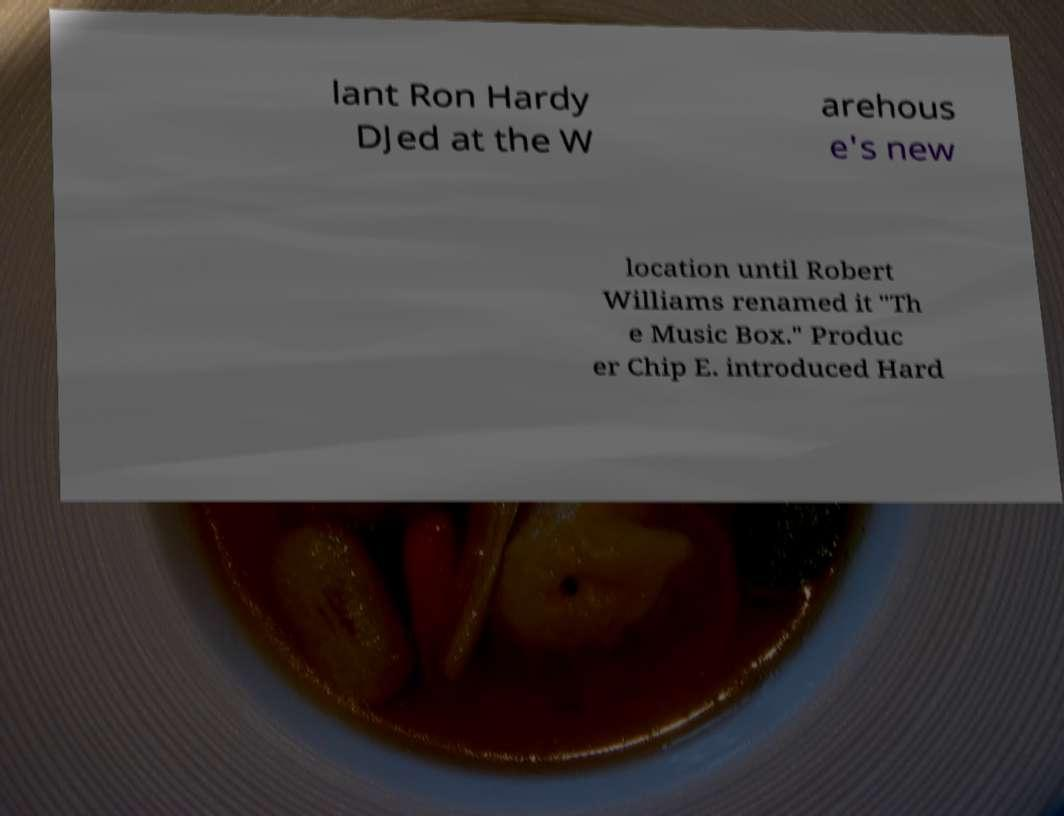There's text embedded in this image that I need extracted. Can you transcribe it verbatim? lant Ron Hardy DJed at the W arehous e's new location until Robert Williams renamed it "Th e Music Box." Produc er Chip E. introduced Hard 